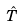Convert formula to latex. <formula><loc_0><loc_0><loc_500><loc_500>\hat { T }</formula> 